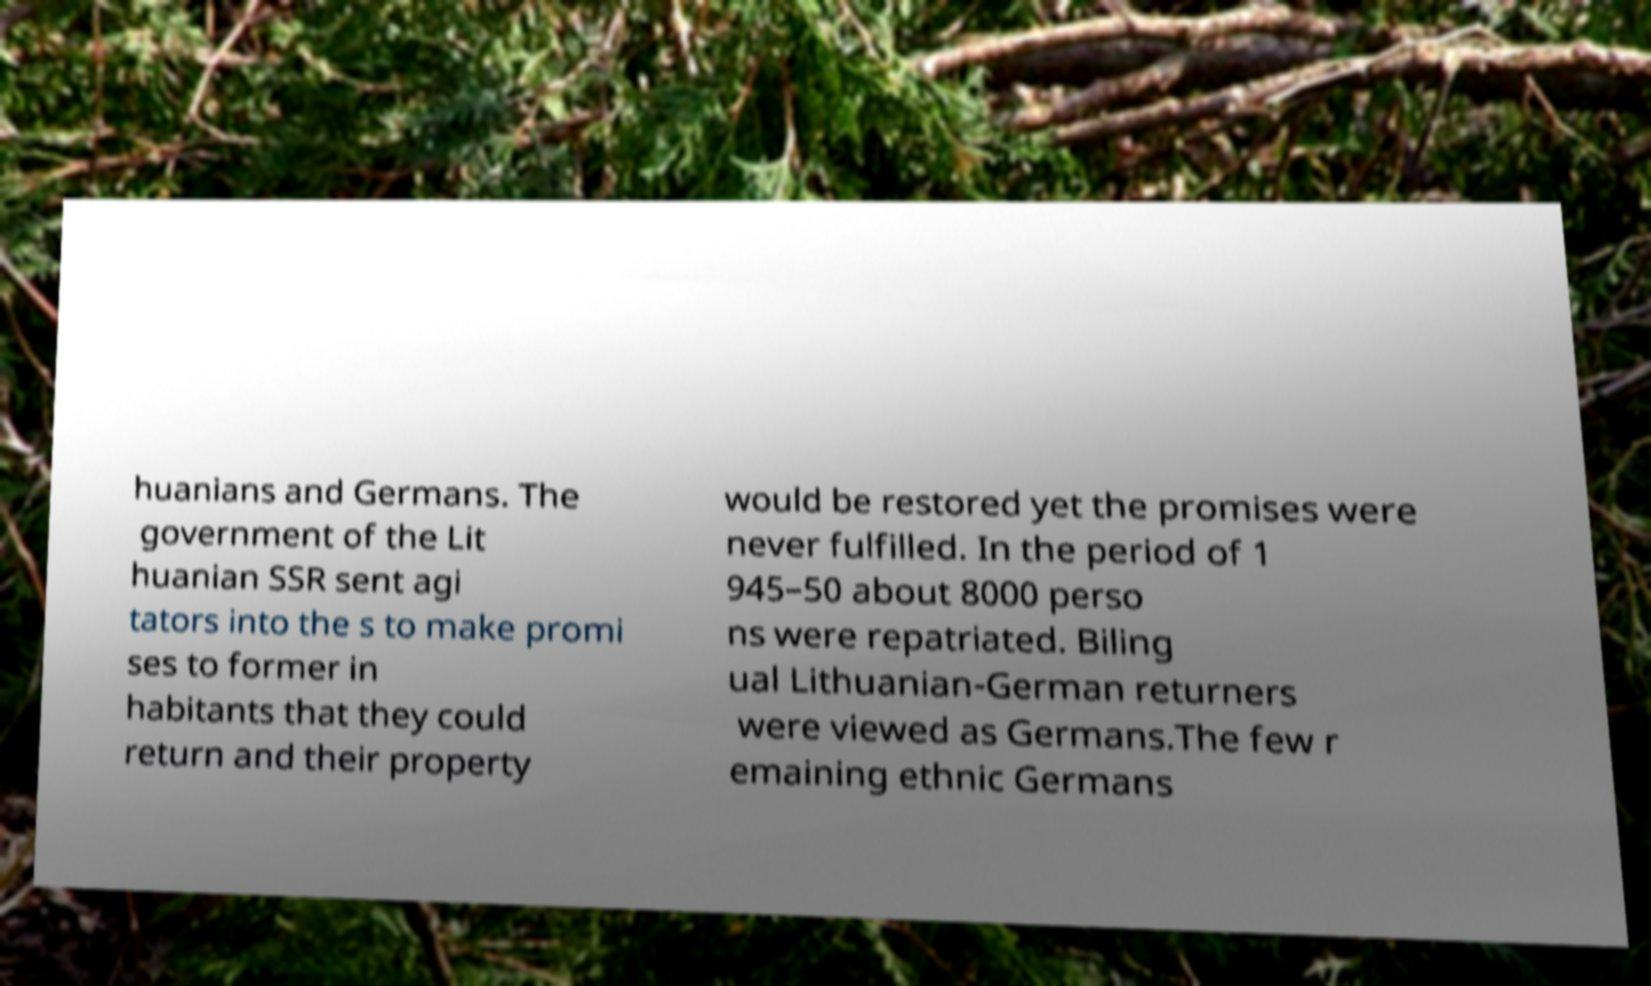Can you read and provide the text displayed in the image?This photo seems to have some interesting text. Can you extract and type it out for me? huanians and Germans. The government of the Lit huanian SSR sent agi tators into the s to make promi ses to former in habitants that they could return and their property would be restored yet the promises were never fulfilled. In the period of 1 945–50 about 8000 perso ns were repatriated. Biling ual Lithuanian-German returners were viewed as Germans.The few r emaining ethnic Germans 